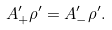<formula> <loc_0><loc_0><loc_500><loc_500>A ^ { \prime } _ { + } \rho ^ { \prime } = A ^ { \prime } _ { - } \rho ^ { \prime } .</formula> 